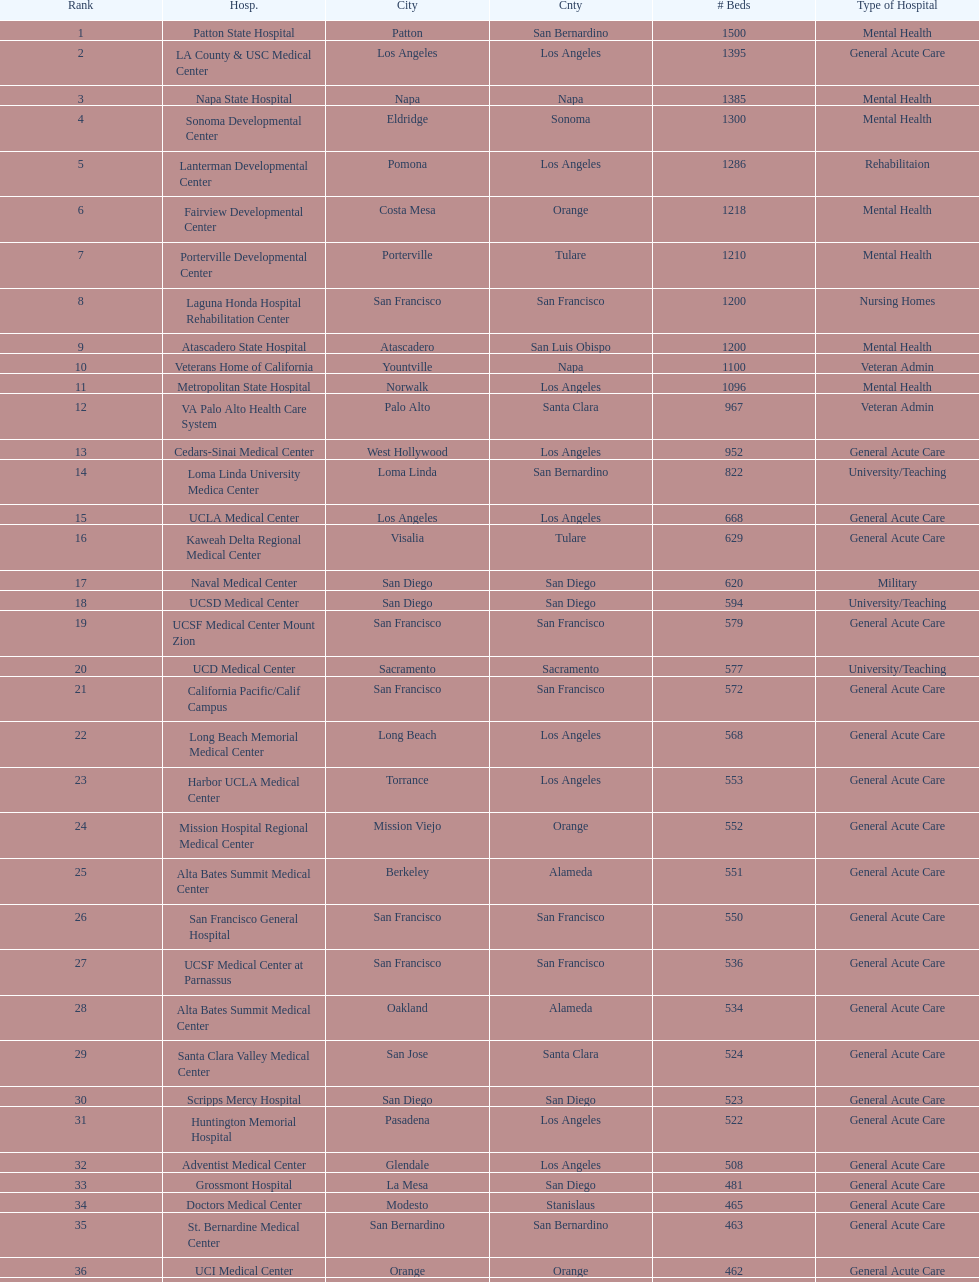How many hospitals have at least 1,000 beds? 11. 